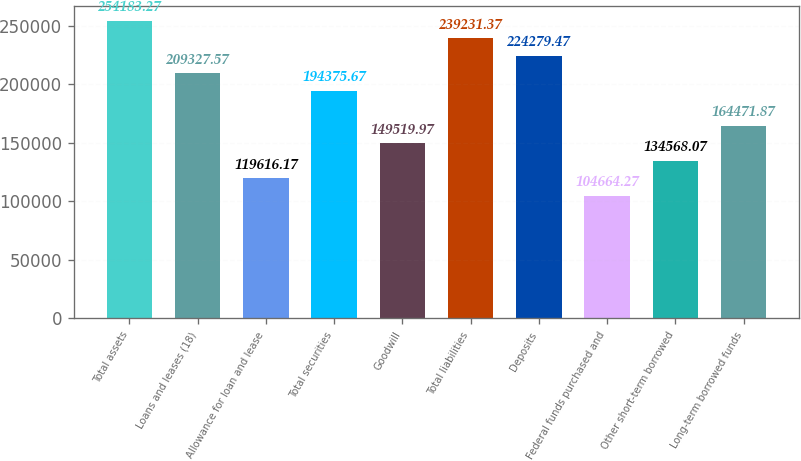Convert chart to OTSL. <chart><loc_0><loc_0><loc_500><loc_500><bar_chart><fcel>Total assets<fcel>Loans and leases (18)<fcel>Allowance for loan and lease<fcel>Total securities<fcel>Goodwill<fcel>Total liabilities<fcel>Deposits<fcel>Federal funds purchased and<fcel>Other short-term borrowed<fcel>Long-term borrowed funds<nl><fcel>254183<fcel>209328<fcel>119616<fcel>194376<fcel>149520<fcel>239231<fcel>224279<fcel>104664<fcel>134568<fcel>164472<nl></chart> 